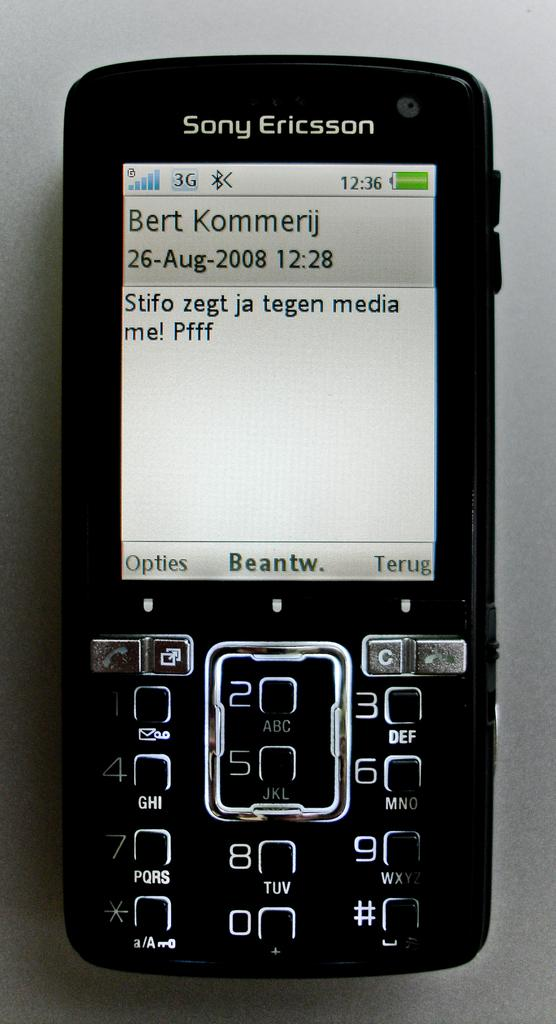<image>
Create a compact narrative representing the image presented. a small black sony ericsson phone with the name 'bert kommerij' on the screen 